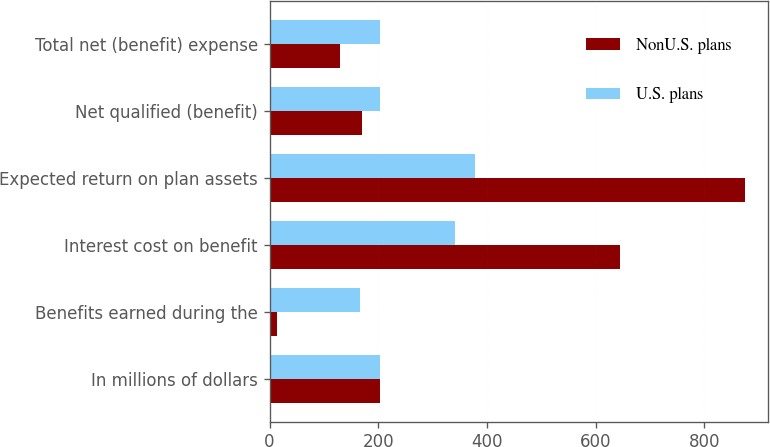<chart> <loc_0><loc_0><loc_500><loc_500><stacked_bar_chart><ecel><fcel>In millions of dollars<fcel>Benefits earned during the<fcel>Interest cost on benefit<fcel>Expected return on plan assets<fcel>Net qualified (benefit)<fcel>Total net (benefit) expense<nl><fcel>NonU.S. plans<fcel>204<fcel>14<fcel>644<fcel>874<fcel>170<fcel>129<nl><fcel>U.S. plans<fcel>204<fcel>167<fcel>342<fcel>378<fcel>204<fcel>204<nl></chart> 